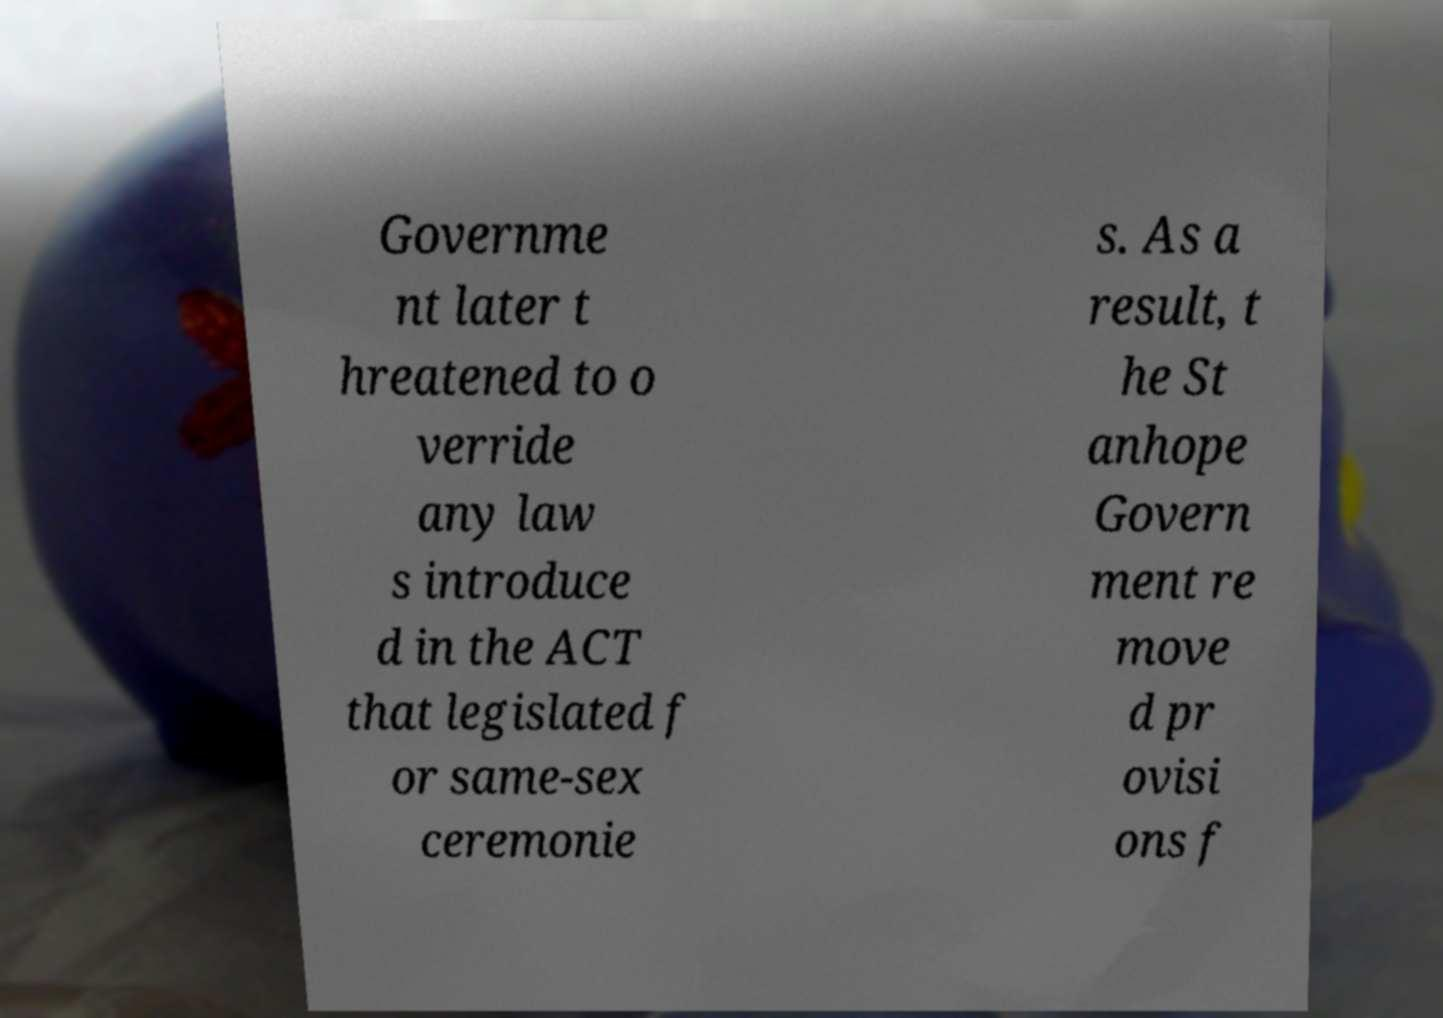Can you read and provide the text displayed in the image?This photo seems to have some interesting text. Can you extract and type it out for me? Governme nt later t hreatened to o verride any law s introduce d in the ACT that legislated f or same-sex ceremonie s. As a result, t he St anhope Govern ment re move d pr ovisi ons f 